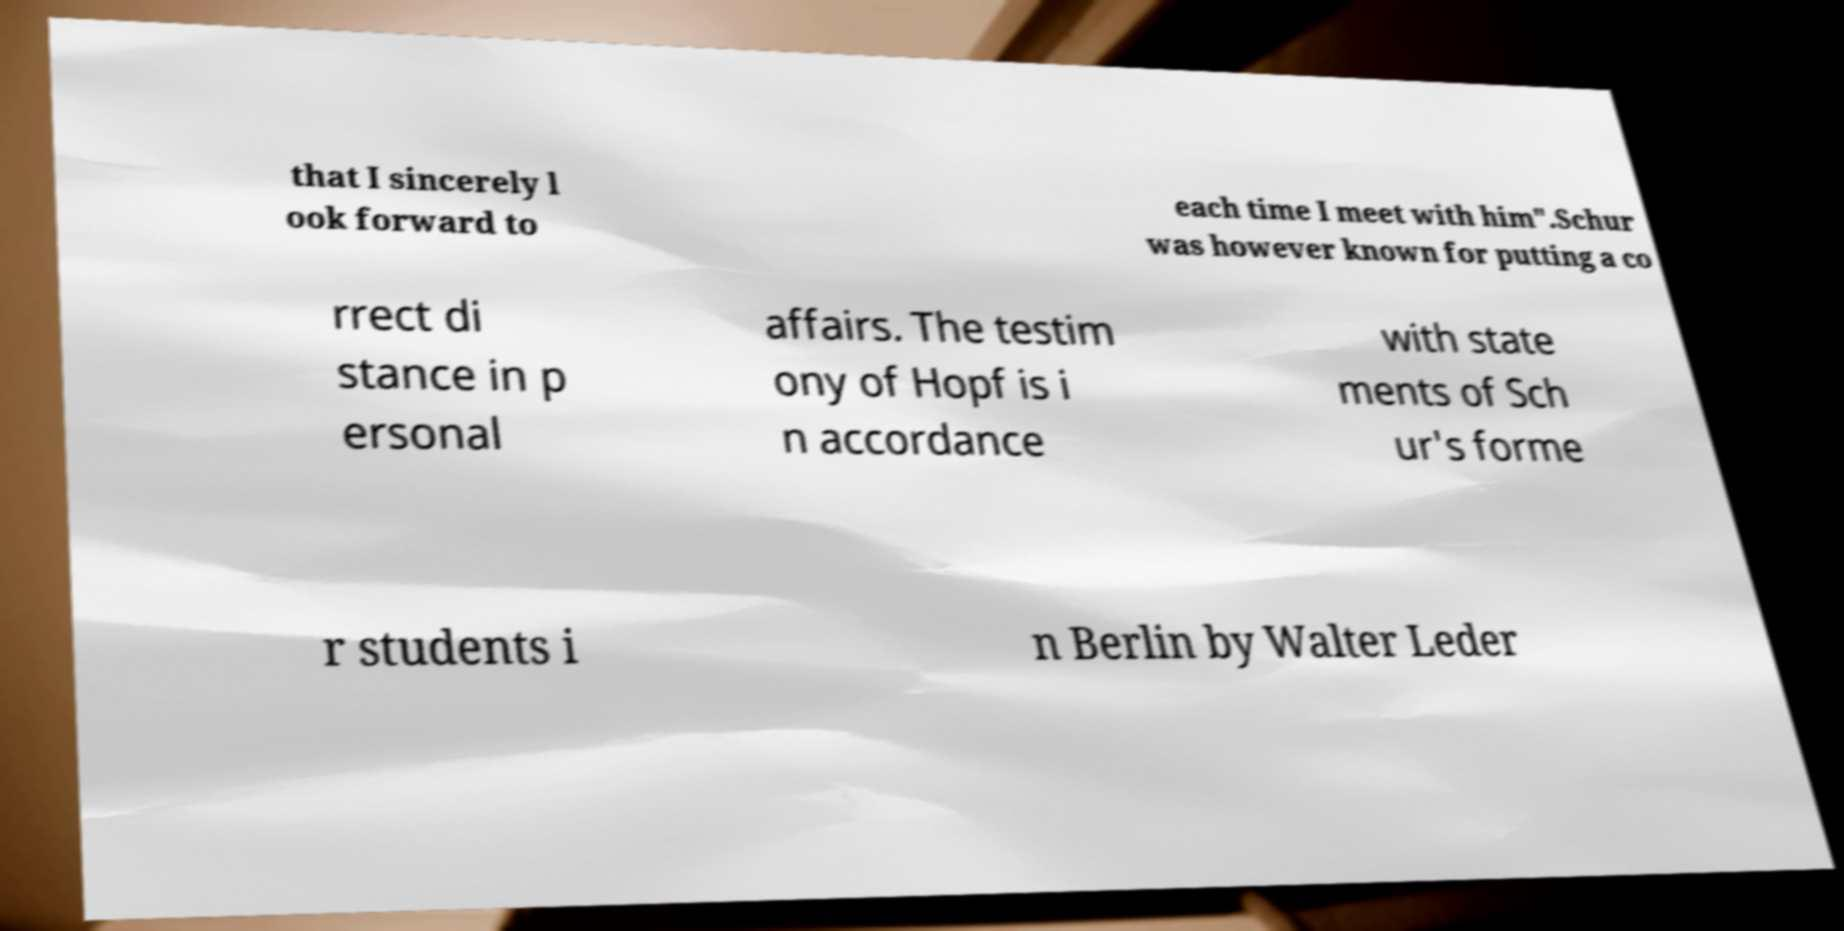Could you extract and type out the text from this image? that I sincerely l ook forward to each time I meet with him".Schur was however known for putting a co rrect di stance in p ersonal affairs. The testim ony of Hopf is i n accordance with state ments of Sch ur's forme r students i n Berlin by Walter Leder 